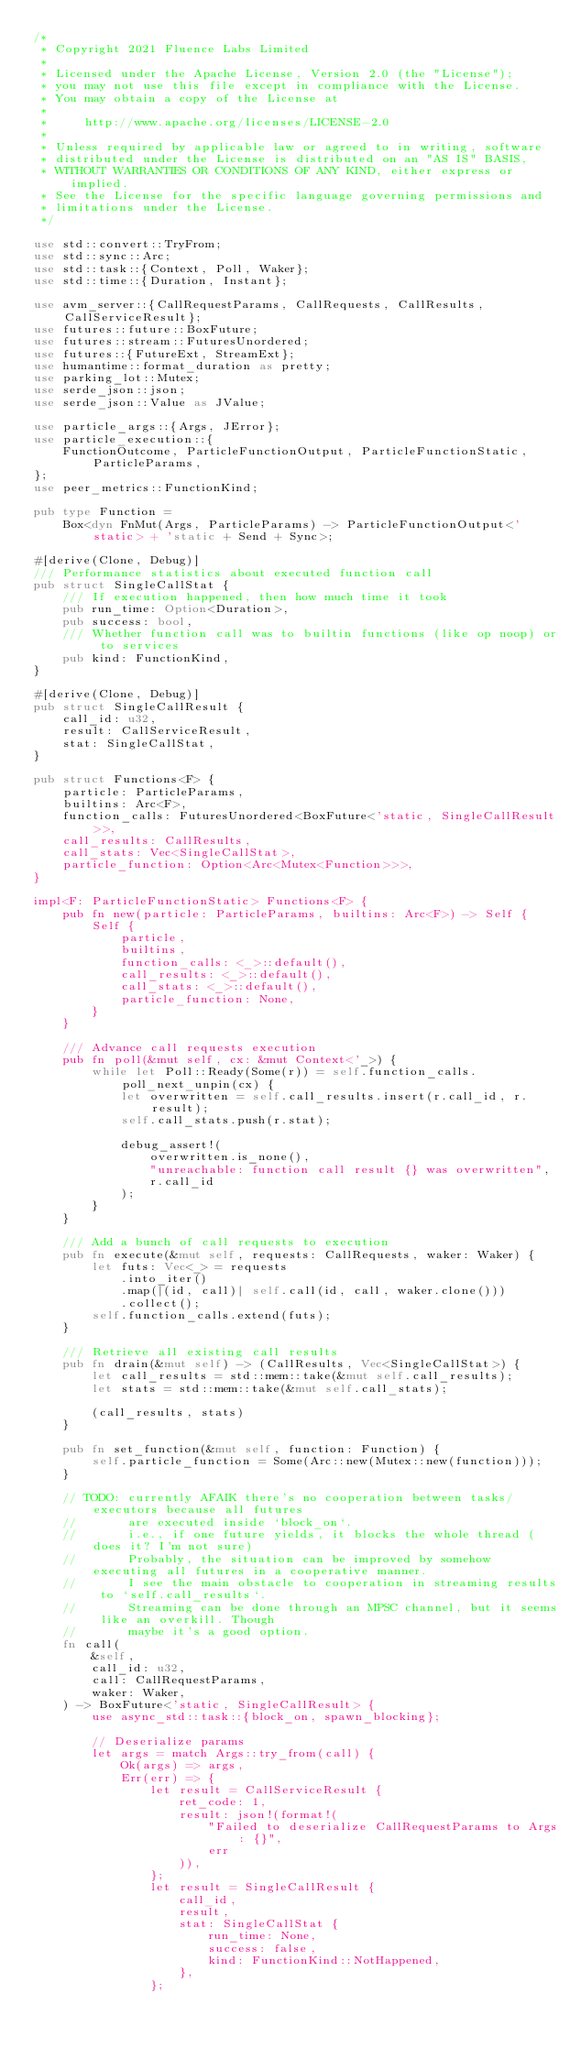Convert code to text. <code><loc_0><loc_0><loc_500><loc_500><_Rust_>/*
 * Copyright 2021 Fluence Labs Limited
 *
 * Licensed under the Apache License, Version 2.0 (the "License");
 * you may not use this file except in compliance with the License.
 * You may obtain a copy of the License at
 *
 *     http://www.apache.org/licenses/LICENSE-2.0
 *
 * Unless required by applicable law or agreed to in writing, software
 * distributed under the License is distributed on an "AS IS" BASIS,
 * WITHOUT WARRANTIES OR CONDITIONS OF ANY KIND, either express or implied.
 * See the License for the specific language governing permissions and
 * limitations under the License.
 */

use std::convert::TryFrom;
use std::sync::Arc;
use std::task::{Context, Poll, Waker};
use std::time::{Duration, Instant};

use avm_server::{CallRequestParams, CallRequests, CallResults, CallServiceResult};
use futures::future::BoxFuture;
use futures::stream::FuturesUnordered;
use futures::{FutureExt, StreamExt};
use humantime::format_duration as pretty;
use parking_lot::Mutex;
use serde_json::json;
use serde_json::Value as JValue;

use particle_args::{Args, JError};
use particle_execution::{
    FunctionOutcome, ParticleFunctionOutput, ParticleFunctionStatic, ParticleParams,
};
use peer_metrics::FunctionKind;

pub type Function =
    Box<dyn FnMut(Args, ParticleParams) -> ParticleFunctionOutput<'static> + 'static + Send + Sync>;

#[derive(Clone, Debug)]
/// Performance statistics about executed function call
pub struct SingleCallStat {
    /// If execution happened, then how much time it took
    pub run_time: Option<Duration>,
    pub success: bool,
    /// Whether function call was to builtin functions (like op noop) or to services
    pub kind: FunctionKind,
}

#[derive(Clone, Debug)]
pub struct SingleCallResult {
    call_id: u32,
    result: CallServiceResult,
    stat: SingleCallStat,
}

pub struct Functions<F> {
    particle: ParticleParams,
    builtins: Arc<F>,
    function_calls: FuturesUnordered<BoxFuture<'static, SingleCallResult>>,
    call_results: CallResults,
    call_stats: Vec<SingleCallStat>,
    particle_function: Option<Arc<Mutex<Function>>>,
}

impl<F: ParticleFunctionStatic> Functions<F> {
    pub fn new(particle: ParticleParams, builtins: Arc<F>) -> Self {
        Self {
            particle,
            builtins,
            function_calls: <_>::default(),
            call_results: <_>::default(),
            call_stats: <_>::default(),
            particle_function: None,
        }
    }

    /// Advance call requests execution
    pub fn poll(&mut self, cx: &mut Context<'_>) {
        while let Poll::Ready(Some(r)) = self.function_calls.poll_next_unpin(cx) {
            let overwritten = self.call_results.insert(r.call_id, r.result);
            self.call_stats.push(r.stat);

            debug_assert!(
                overwritten.is_none(),
                "unreachable: function call result {} was overwritten",
                r.call_id
            );
        }
    }

    /// Add a bunch of call requests to execution
    pub fn execute(&mut self, requests: CallRequests, waker: Waker) {
        let futs: Vec<_> = requests
            .into_iter()
            .map(|(id, call)| self.call(id, call, waker.clone()))
            .collect();
        self.function_calls.extend(futs);
    }

    /// Retrieve all existing call results
    pub fn drain(&mut self) -> (CallResults, Vec<SingleCallStat>) {
        let call_results = std::mem::take(&mut self.call_results);
        let stats = std::mem::take(&mut self.call_stats);

        (call_results, stats)
    }

    pub fn set_function(&mut self, function: Function) {
        self.particle_function = Some(Arc::new(Mutex::new(function)));
    }

    // TODO: currently AFAIK there's no cooperation between tasks/executors because all futures
    //       are executed inside `block_on`.
    //       i.e., if one future yields, it blocks the whole thread (does it? I'm not sure)
    //       Probably, the situation can be improved by somehow executing all futures in a cooperative manner.
    //       I see the main obstacle to cooperation in streaming results to `self.call_results`.
    //       Streaming can be done through an MPSC channel, but it seems like an overkill. Though
    //       maybe it's a good option.
    fn call(
        &self,
        call_id: u32,
        call: CallRequestParams,
        waker: Waker,
    ) -> BoxFuture<'static, SingleCallResult> {
        use async_std::task::{block_on, spawn_blocking};

        // Deserialize params
        let args = match Args::try_from(call) {
            Ok(args) => args,
            Err(err) => {
                let result = CallServiceResult {
                    ret_code: 1,
                    result: json!(format!(
                        "Failed to deserialize CallRequestParams to Args: {}",
                        err
                    )),
                };
                let result = SingleCallResult {
                    call_id,
                    result,
                    stat: SingleCallStat {
                        run_time: None,
                        success: false,
                        kind: FunctionKind::NotHappened,
                    },
                };</code> 